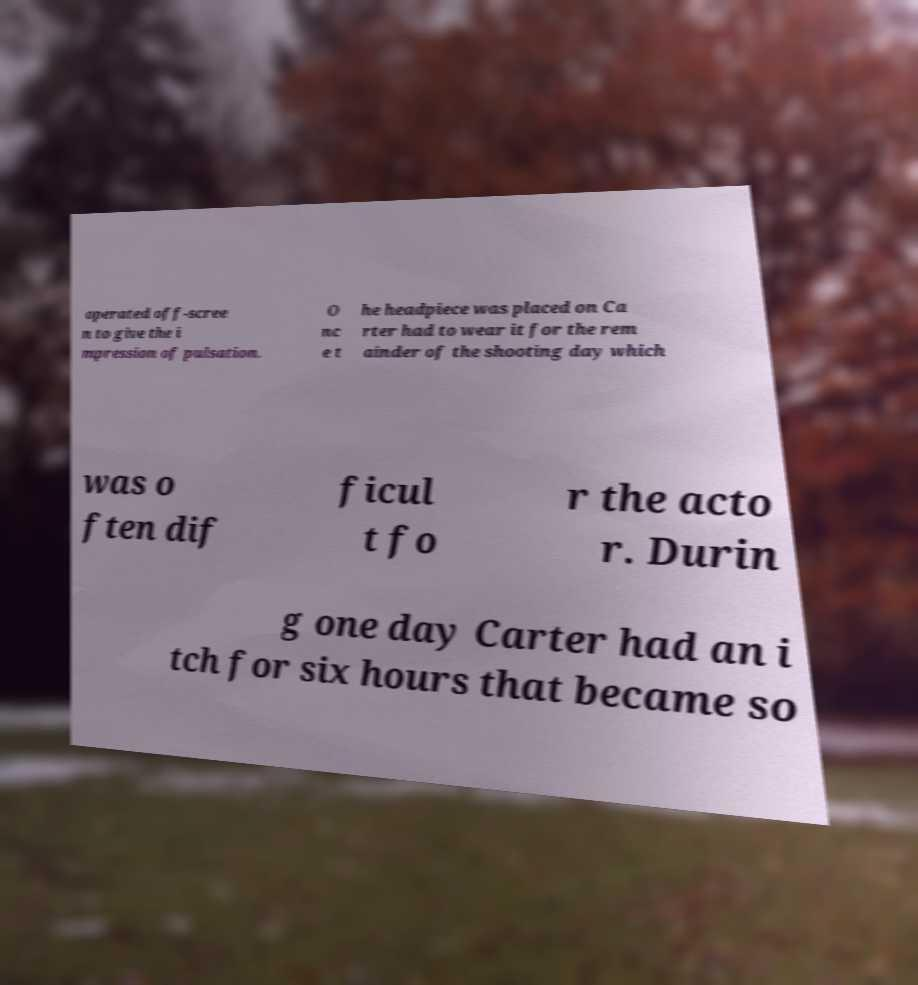Please identify and transcribe the text found in this image. operated off-scree n to give the i mpression of pulsation. O nc e t he headpiece was placed on Ca rter had to wear it for the rem ainder of the shooting day which was o ften dif ficul t fo r the acto r. Durin g one day Carter had an i tch for six hours that became so 